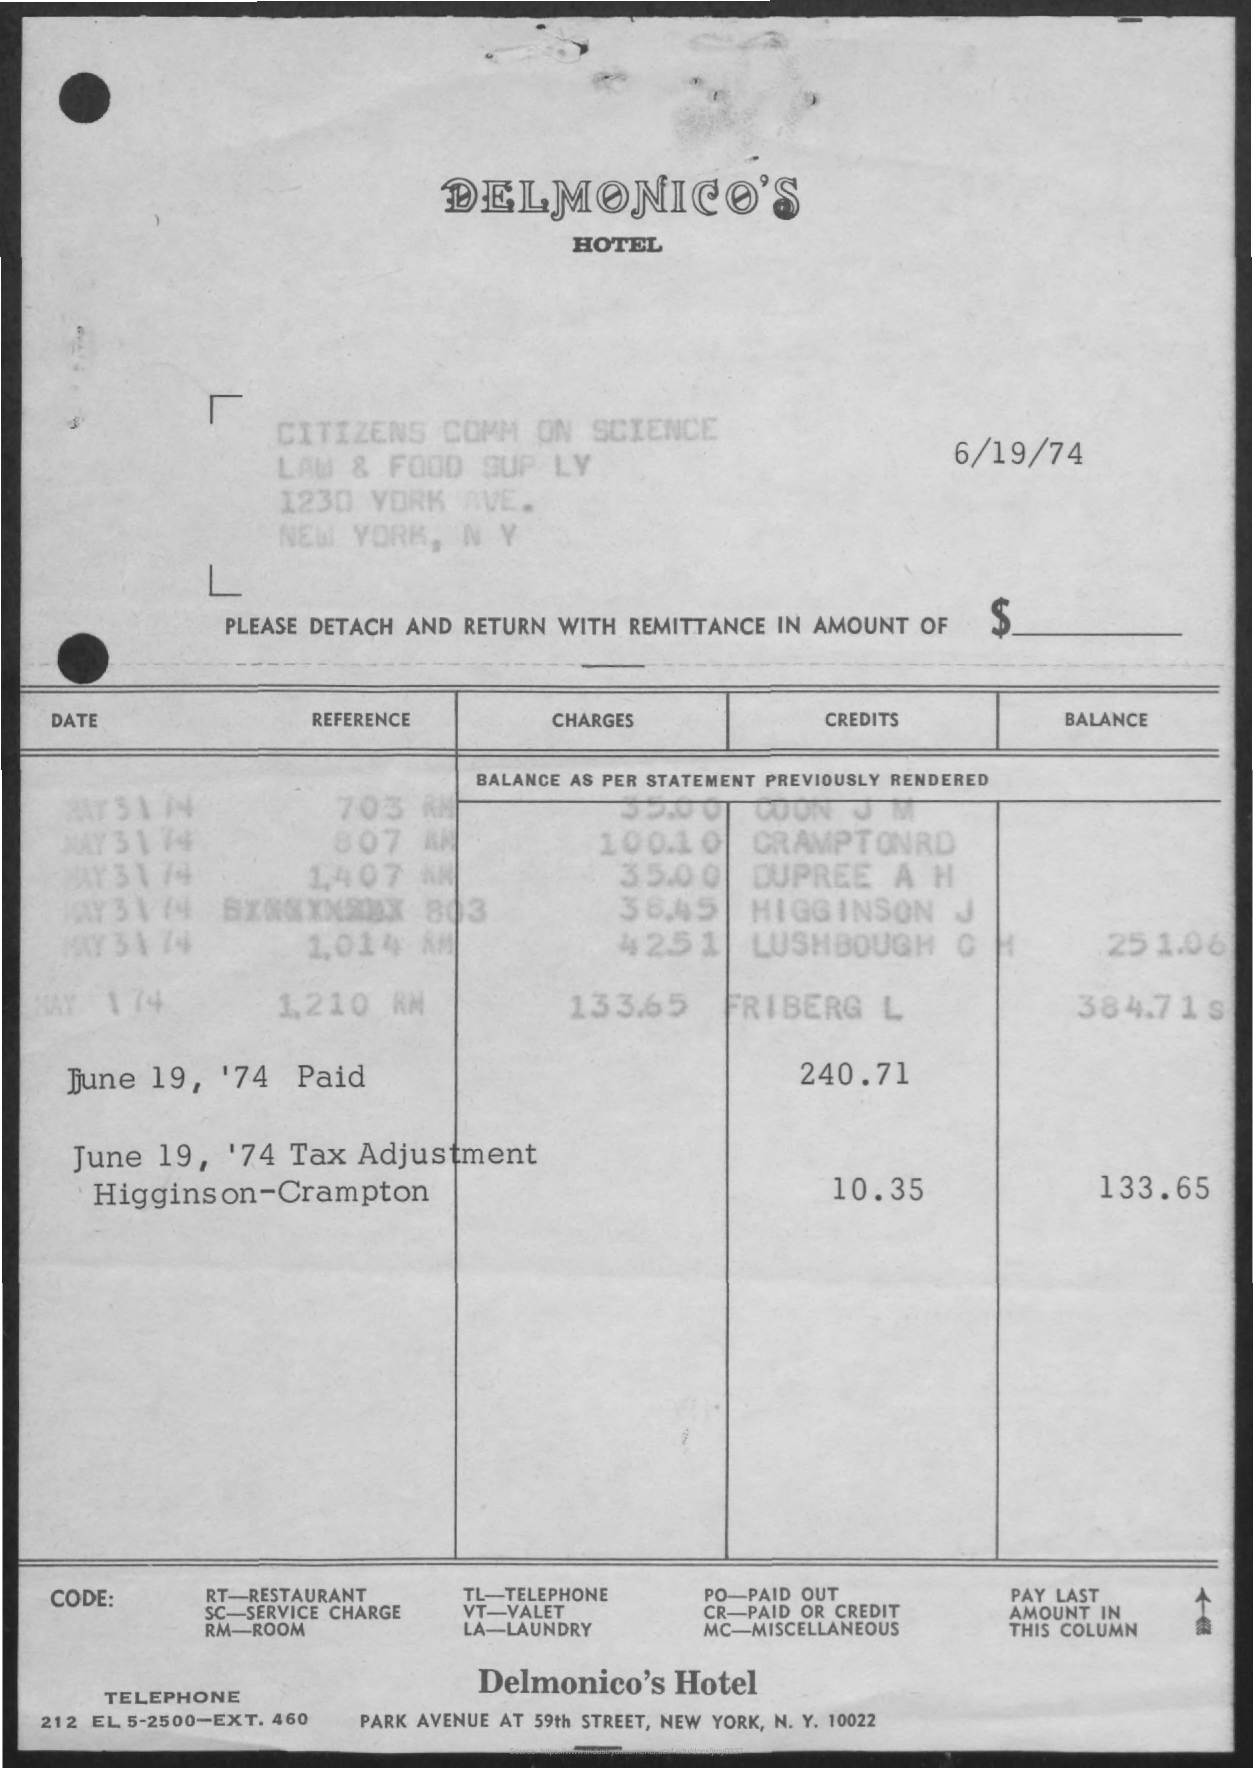What is the first title in the document?
Offer a very short reply. Delmonico's. What is the code for Room?
Your answer should be compact. Rm. What is the code for Paid or Credit?
Make the answer very short. Cr. What is the date mentioned at the top right of the document?
Provide a short and direct response. 6/19/74. 